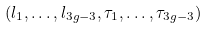<formula> <loc_0><loc_0><loc_500><loc_500>( l _ { 1 } , \dots , l _ { 3 g - 3 } , \tau _ { 1 } , \dots , \tau _ { 3 g - 3 } )</formula> 